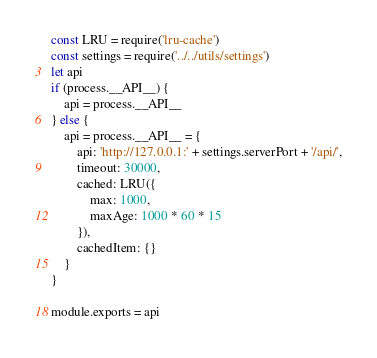Convert code to text. <code><loc_0><loc_0><loc_500><loc_500><_JavaScript_>const LRU = require('lru-cache')
const settings = require('../../utils/settings')
let api
if (process.__API__) {
    api = process.__API__
} else {
    api = process.__API__ = {
        api: 'http://127.0.0.1:' + settings.serverPort + '/api/',
        timeout: 30000,
        cached: LRU({
            max: 1000,
            maxAge: 1000 * 60 * 15
        }),
        cachedItem: {}
    }
}

module.exports = api
</code> 